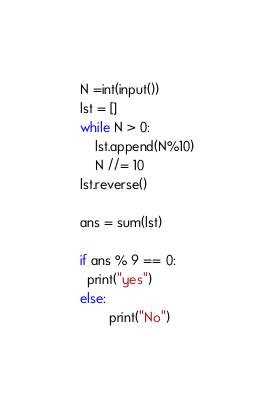Convert code to text. <code><loc_0><loc_0><loc_500><loc_500><_Python_>N =int(input())
lst = []
while N > 0:
    lst.append(N%10)
    N //= 10 
lst.reverse()

ans = sum(lst)

if ans % 9 == 0:
  print("yes")
else:
        print("No")</code> 